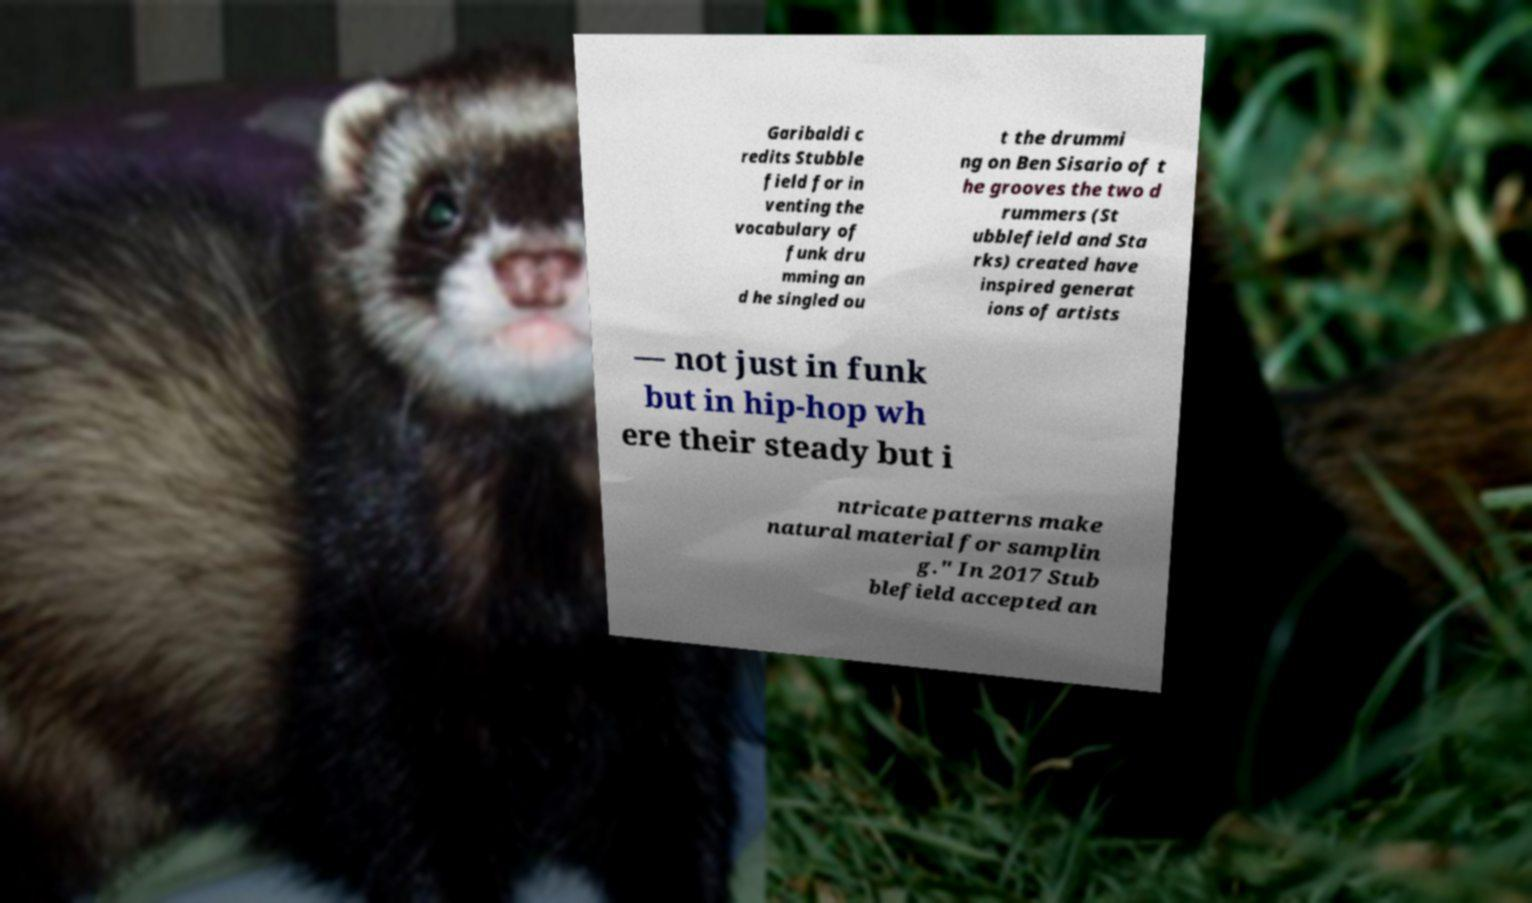For documentation purposes, I need the text within this image transcribed. Could you provide that? Garibaldi c redits Stubble field for in venting the vocabulary of funk dru mming an d he singled ou t the drummi ng on Ben Sisario of t he grooves the two d rummers (St ubblefield and Sta rks) created have inspired generat ions of artists — not just in funk but in hip-hop wh ere their steady but i ntricate patterns make natural material for samplin g." In 2017 Stub blefield accepted an 